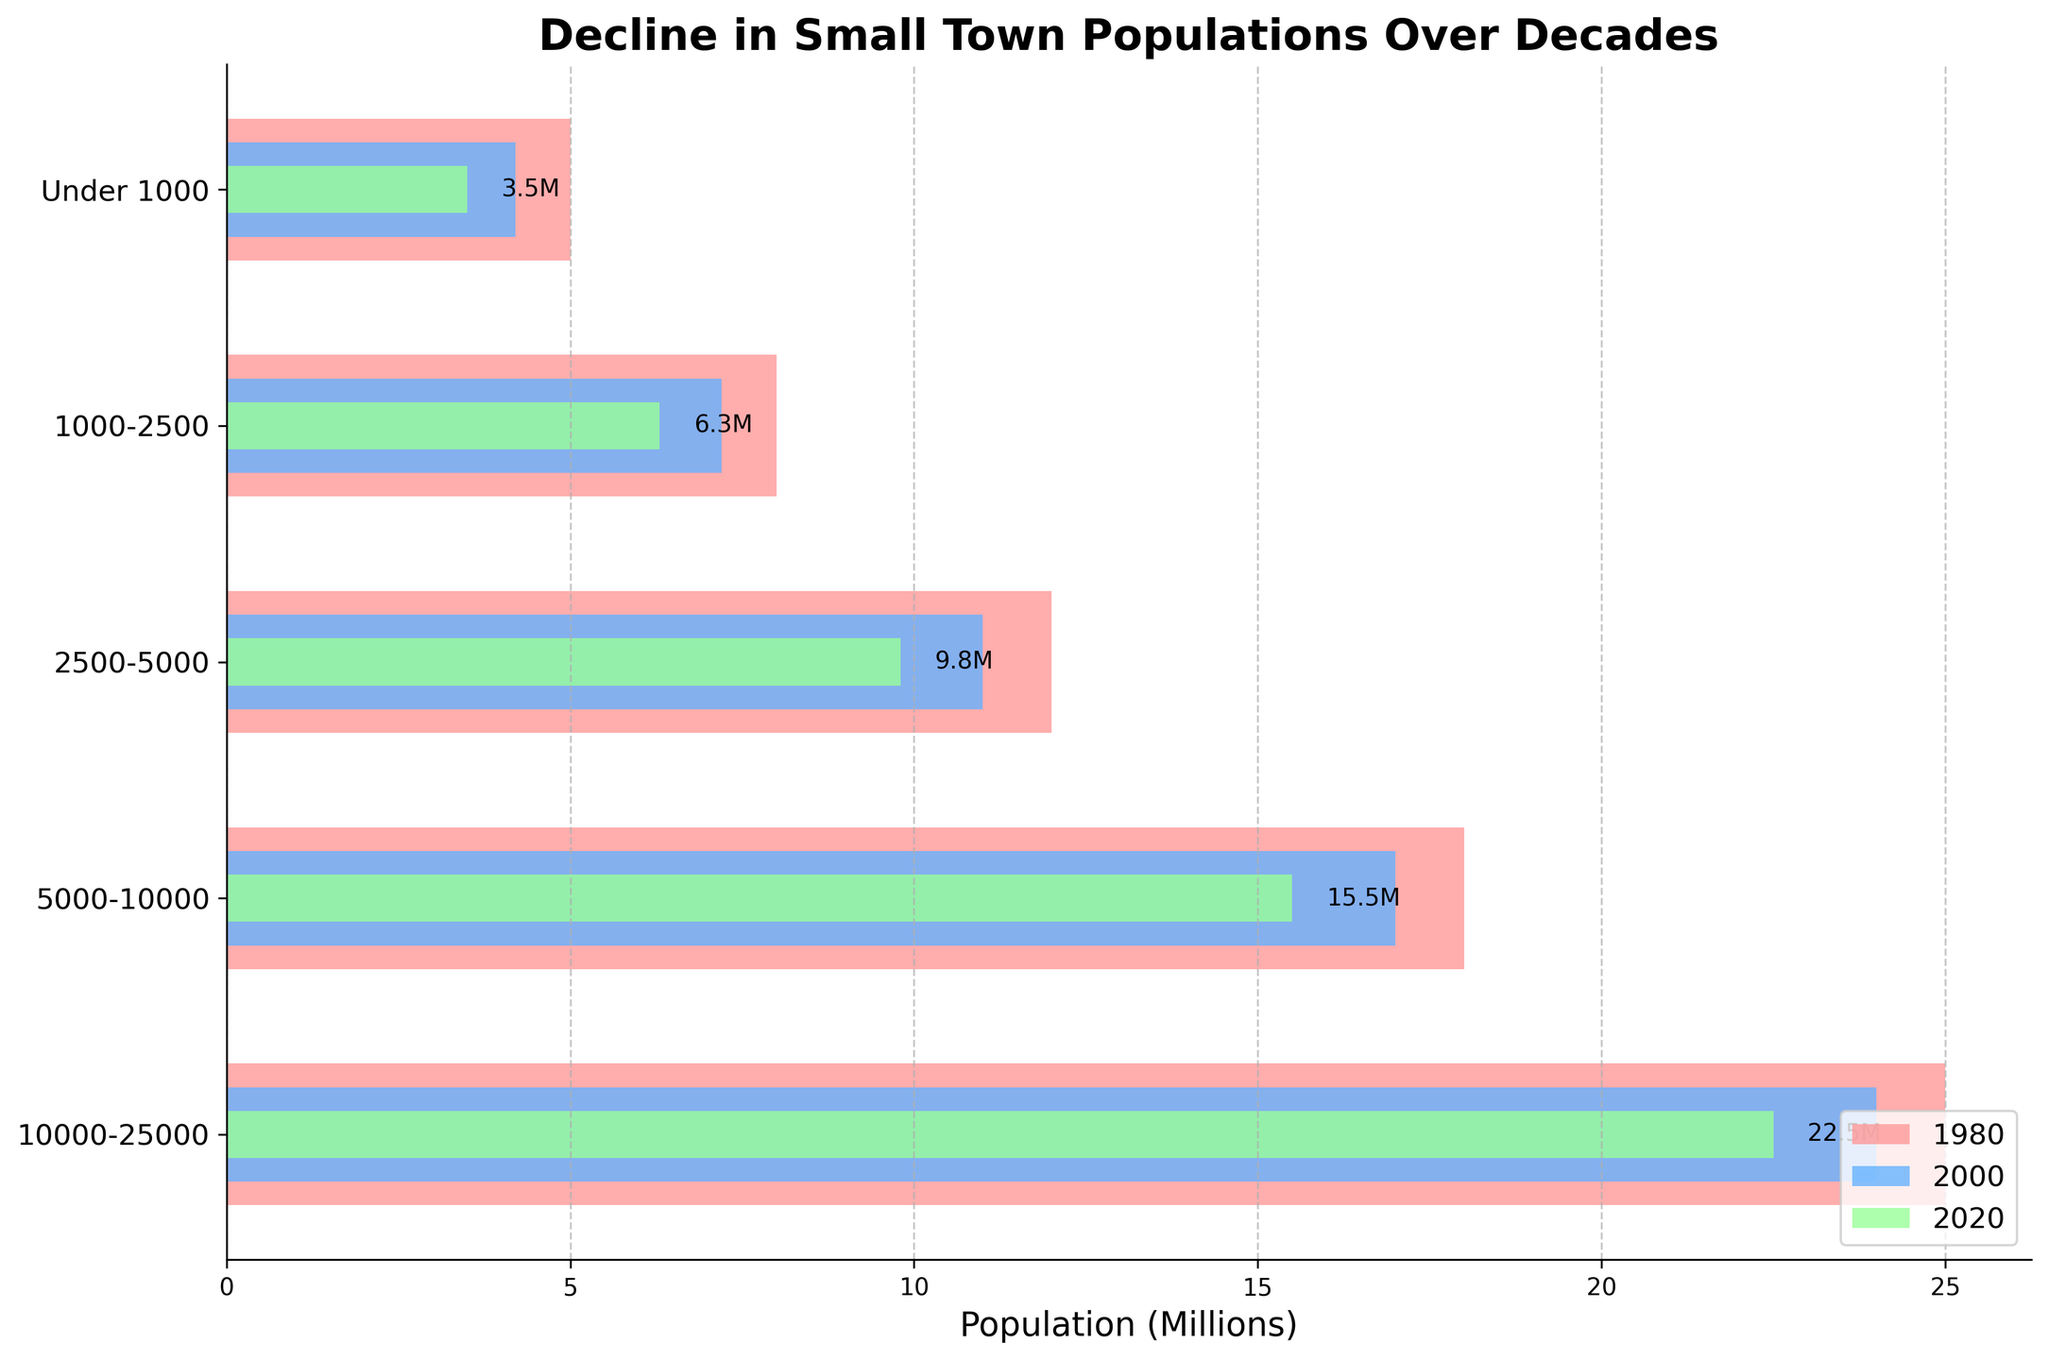what is the title of the figure? The title can be found at the top of the figure. It provides an overview of the content being displayed. In this case, it reads "Decline in Small Town Populations Over Decades".
Answer: Decline in Small Town Populations Over Decades what is the population of towns under 1000 in 2020? Locate the green bar corresponding to "Under 1000" on the y-axis and read the value on the x-axis. The green bar, representing 2020, shows a population of 3.5 million.
Answer: 3.5 million which decade shows the highest population for towns in the range 5000-10000? Compare the lengths of the bars for each decade within the "5000-10000" category. The longest bar is red, representing 1980.
Answer: 1980 what is the total population of towns with sizes 2500 to 5000 and 10000 to 25000 in 2000? Add the population for "2500-5000" and "10000-25000" from the year 2000. They are 11 million and 24 million, respectively. The sum is 11 + 24 = 35 million.
Answer: 35 million which category has the smallest population decline from 2000 to 2020? Calculate the difference for each category between the years 2000 and 2020. The smallest decline is seen in the "10000-25000" category, from 24 million to 22.5 million, a decrease of 1.5 million.
Answer: 10000-25000 how much has the population of towns sized 1000-2500 decreased from 1980 to 2020? Subtract the population of the year 2020 from the population of the year 1980 for the "1000-2500" category: 8 million - 6.3 million = 1.7 million.
Answer: 1.7 million which year has the highest total population across all town sizes? Sum the populations for each year across all categories. For 1980: 5 + 8 + 12 + 18 + 25 = 68 million. For 2000: 4.2 + 7.2 + 11 + 17 + 24 = 63.4 million. For 2020: 3.5 + 6.3 + 9.8 + 15.5 + 22.5 = 57.6 million. The highest is in 1980.
Answer: 1980 which category shows the largest population decline from 1980 to 2020? Calculate the decline for each category from 1980 to 2020. The largest decline is in the "5000-10000" category: 18 million - 15.5 million = 2.5 million.
Answer: 5000-10000 which town size range had the smallest population in all three decades? Compare the populations across all three decades for each category. The "Under 1000" category consistently has the smallest population in 1980, 2000, and 2020.
Answer: Under 1000 